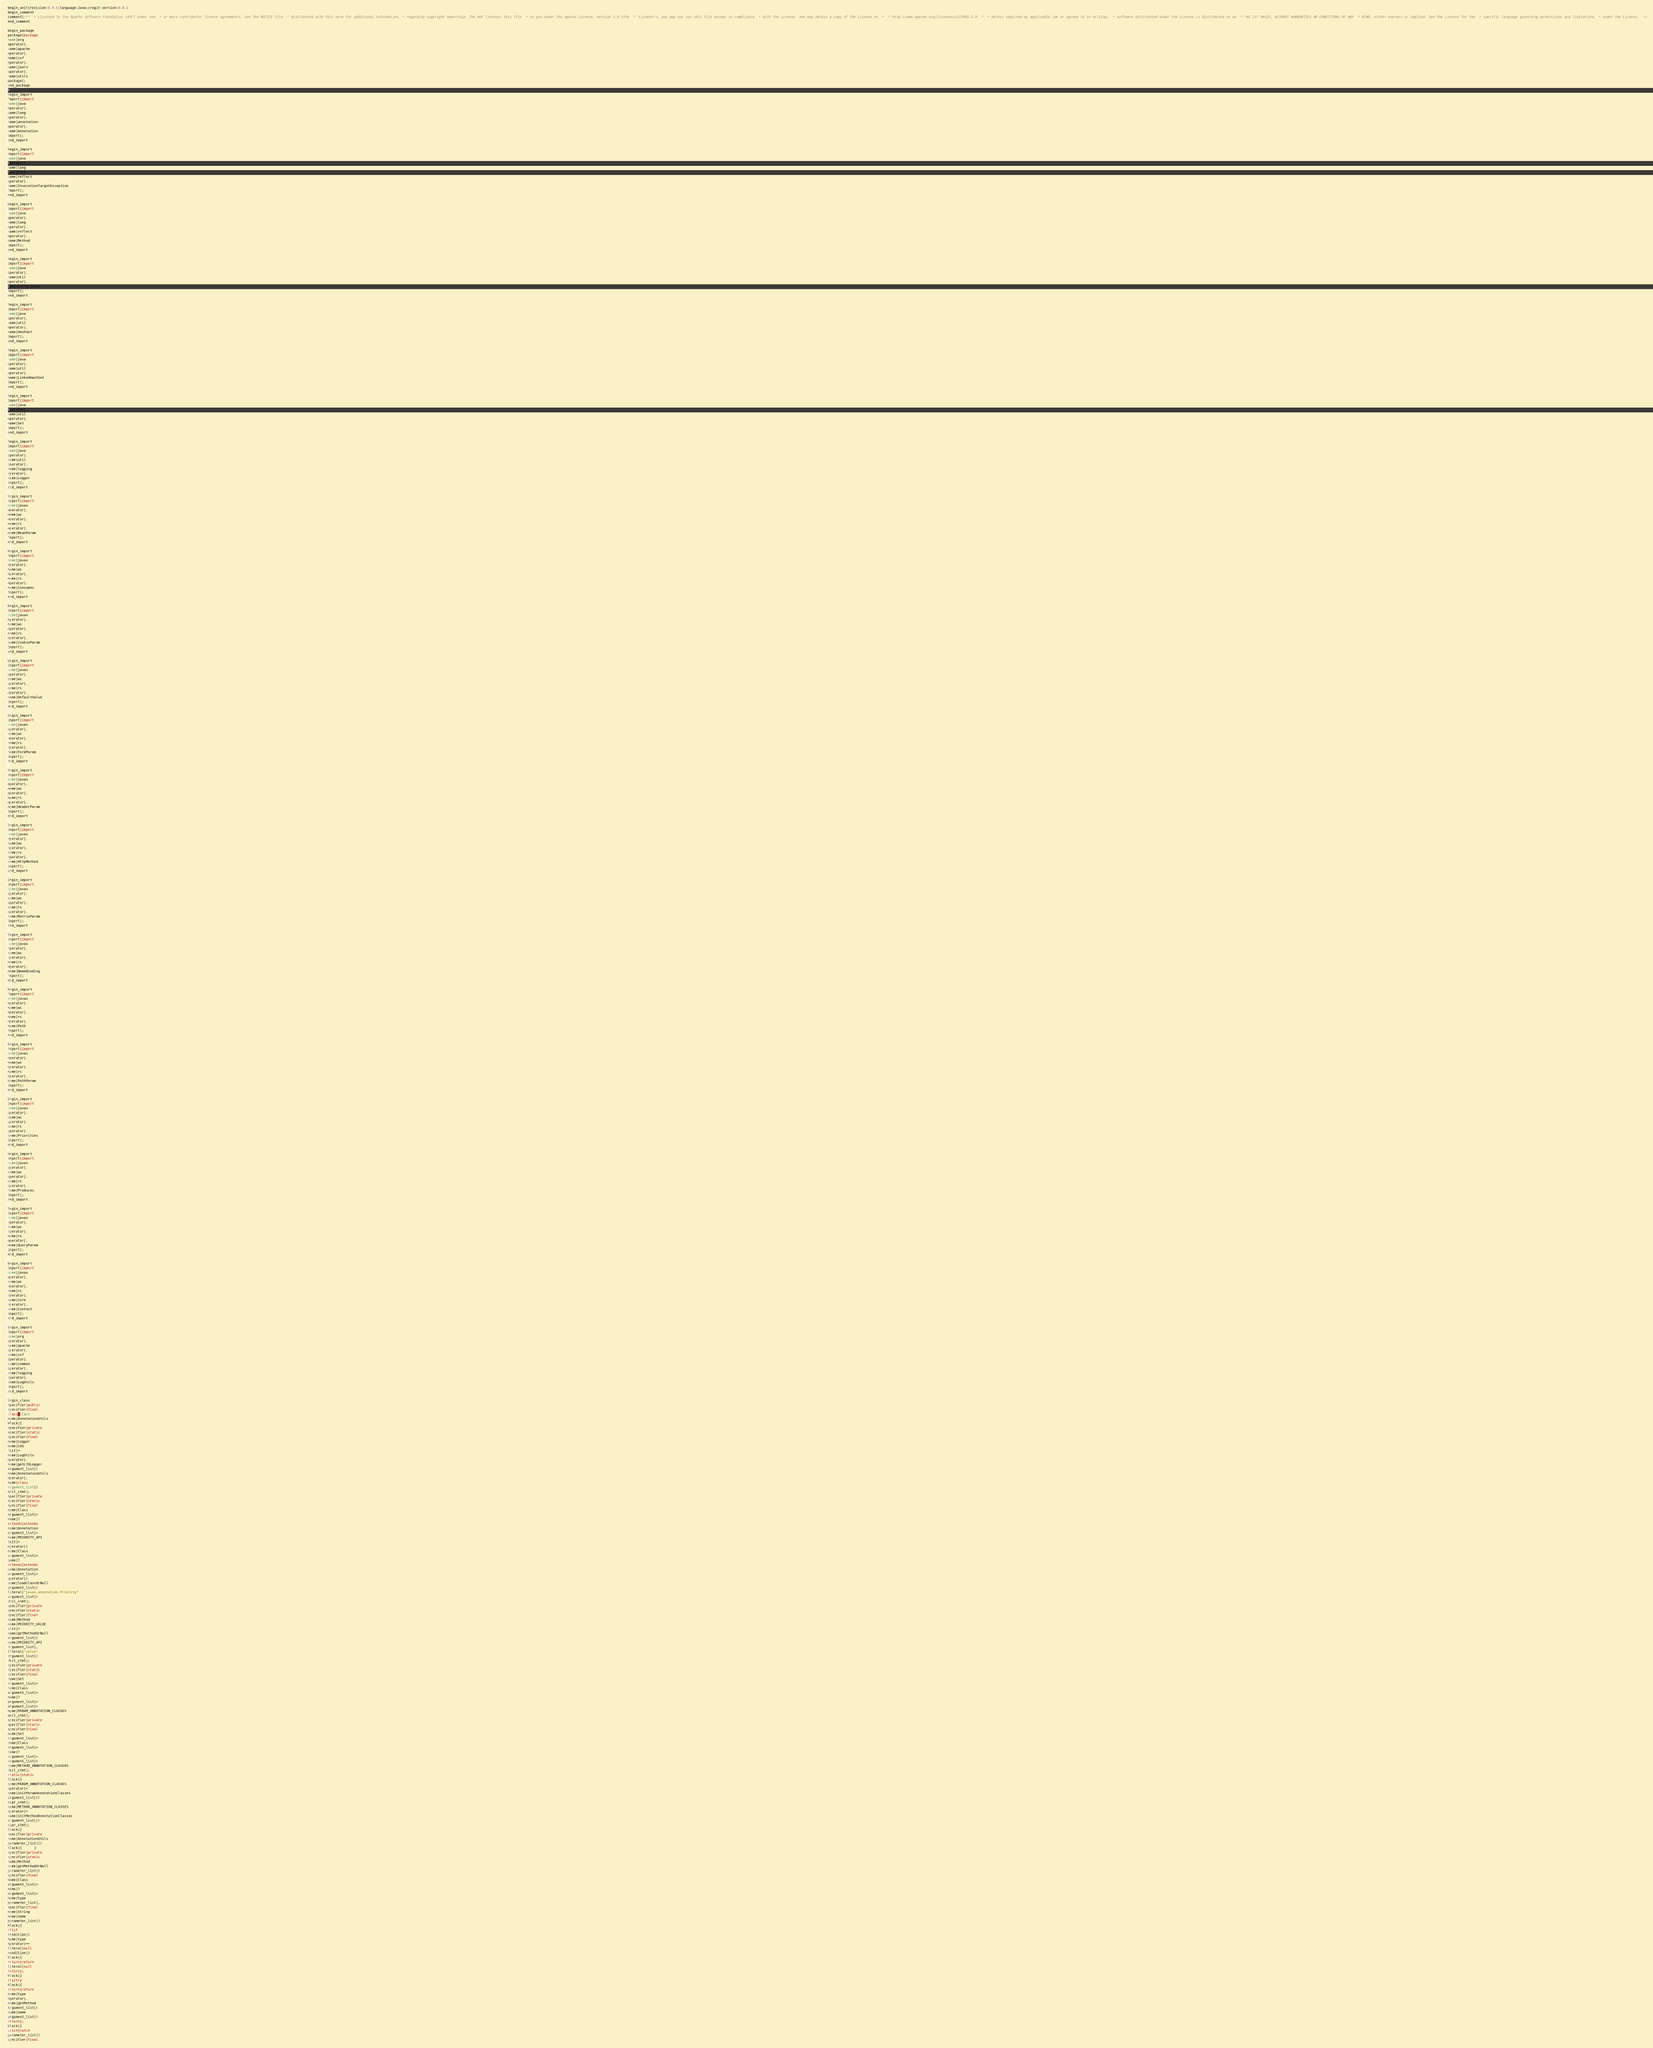<code> <loc_0><loc_0><loc_500><loc_500><_Java_>begin_unit|revision:0.9.5;language:Java;cregit-version:0.0.1
begin_comment
comment|/**  * Licensed to the Apache Software Foundation (ASF) under one  * or more contributor license agreements. See the NOTICE file  * distributed with this work for additional information  * regarding copyright ownership. The ASF licenses this file  * to you under the Apache License, Version 2.0 (the  * "License"); you may not use this file except in compliance  * with the License. You may obtain a copy of the License at  *  * http://www.apache.org/licenses/LICENSE-2.0  *  * Unless required by applicable law or agreed to in writing,  * software distributed under the License is distributed on an  * "AS IS" BASIS, WITHOUT WARRANTIES OR CONDITIONS OF ANY  * KIND, either express or implied. See the License for the  * specific language governing permissions and limitations  * under the License.  */
end_comment

begin_package
package|package
name|org
operator|.
name|apache
operator|.
name|cxf
operator|.
name|jaxrs
operator|.
name|utils
package|;
end_package

begin_import
import|import
name|java
operator|.
name|lang
operator|.
name|annotation
operator|.
name|Annotation
import|;
end_import

begin_import
import|import
name|java
operator|.
name|lang
operator|.
name|reflect
operator|.
name|InvocationTargetException
import|;
end_import

begin_import
import|import
name|java
operator|.
name|lang
operator|.
name|reflect
operator|.
name|Method
import|;
end_import

begin_import
import|import
name|java
operator|.
name|util
operator|.
name|Collections
import|;
end_import

begin_import
import|import
name|java
operator|.
name|util
operator|.
name|HashSet
import|;
end_import

begin_import
import|import
name|java
operator|.
name|util
operator|.
name|LinkedHashSet
import|;
end_import

begin_import
import|import
name|java
operator|.
name|util
operator|.
name|Set
import|;
end_import

begin_import
import|import
name|java
operator|.
name|util
operator|.
name|logging
operator|.
name|Logger
import|;
end_import

begin_import
import|import
name|javax
operator|.
name|ws
operator|.
name|rs
operator|.
name|BeanParam
import|;
end_import

begin_import
import|import
name|javax
operator|.
name|ws
operator|.
name|rs
operator|.
name|Consumes
import|;
end_import

begin_import
import|import
name|javax
operator|.
name|ws
operator|.
name|rs
operator|.
name|CookieParam
import|;
end_import

begin_import
import|import
name|javax
operator|.
name|ws
operator|.
name|rs
operator|.
name|DefaultValue
import|;
end_import

begin_import
import|import
name|javax
operator|.
name|ws
operator|.
name|rs
operator|.
name|FormParam
import|;
end_import

begin_import
import|import
name|javax
operator|.
name|ws
operator|.
name|rs
operator|.
name|HeaderParam
import|;
end_import

begin_import
import|import
name|javax
operator|.
name|ws
operator|.
name|rs
operator|.
name|HttpMethod
import|;
end_import

begin_import
import|import
name|javax
operator|.
name|ws
operator|.
name|rs
operator|.
name|MatrixParam
import|;
end_import

begin_import
import|import
name|javax
operator|.
name|ws
operator|.
name|rs
operator|.
name|NameBinding
import|;
end_import

begin_import
import|import
name|javax
operator|.
name|ws
operator|.
name|rs
operator|.
name|Path
import|;
end_import

begin_import
import|import
name|javax
operator|.
name|ws
operator|.
name|rs
operator|.
name|PathParam
import|;
end_import

begin_import
import|import
name|javax
operator|.
name|ws
operator|.
name|rs
operator|.
name|Priorities
import|;
end_import

begin_import
import|import
name|javax
operator|.
name|ws
operator|.
name|rs
operator|.
name|Produces
import|;
end_import

begin_import
import|import
name|javax
operator|.
name|ws
operator|.
name|rs
operator|.
name|QueryParam
import|;
end_import

begin_import
import|import
name|javax
operator|.
name|ws
operator|.
name|rs
operator|.
name|core
operator|.
name|Context
import|;
end_import

begin_import
import|import
name|org
operator|.
name|apache
operator|.
name|cxf
operator|.
name|common
operator|.
name|logging
operator|.
name|LogUtils
import|;
end_import

begin_class
specifier|public
specifier|final
class|class
name|AnnotationUtils
block|{
specifier|private
specifier|static
specifier|final
name|Logger
name|LOG
init|=
name|LogUtils
operator|.
name|getL7dLogger
argument_list|(
name|AnnotationUtils
operator|.
name|class
argument_list|)
decl_stmt|;
specifier|private
specifier|static
specifier|final
name|Class
argument_list|<
name|?
extends|extends
name|Annotation
argument_list|>
name|PRIORITY_API
init|=
operator|(
name|Class
argument_list|<
name|?
extends|extends
name|Annotation
argument_list|>
operator|)
name|loadClassOrNull
argument_list|(
literal|"javax.annotation.Priority"
argument_list|)
decl_stmt|;
specifier|private
specifier|static
specifier|final
name|Method
name|PRIORITY_VALUE
init|=
name|getMethodOrNull
argument_list|(
name|PRIORITY_API
argument_list|,
literal|"value"
argument_list|)
decl_stmt|;
specifier|private
specifier|static
specifier|final
name|Set
argument_list|<
name|Class
argument_list|<
name|?
argument_list|>
argument_list|>
name|PARAM_ANNOTATION_CLASSES
decl_stmt|;
specifier|private
specifier|static
specifier|final
name|Set
argument_list|<
name|Class
argument_list|<
name|?
argument_list|>
argument_list|>
name|METHOD_ANNOTATION_CLASSES
decl_stmt|;
static|static
block|{
name|PARAM_ANNOTATION_CLASSES
operator|=
name|initParamAnnotationClasses
argument_list|()
expr_stmt|;
name|METHOD_ANNOTATION_CLASSES
operator|=
name|initMethodAnnotationClasses
argument_list|()
expr_stmt|;
block|}
specifier|private
name|AnnotationUtils
parameter_list|()
block|{      }
specifier|private
specifier|static
name|Method
name|getMethodOrNull
parameter_list|(
specifier|final
name|Class
argument_list|<
name|?
argument_list|>
name|type
parameter_list|,
specifier|final
name|String
name|name
parameter_list|)
block|{
if|if
condition|(
name|type
operator|==
literal|null
condition|)
block|{
return|return
literal|null
return|;
block|}
try|try
block|{
return|return
name|type
operator|.
name|getMethod
argument_list|(
name|name
argument_list|)
return|;
block|}
catch|catch
parameter_list|(
specifier|final</code> 